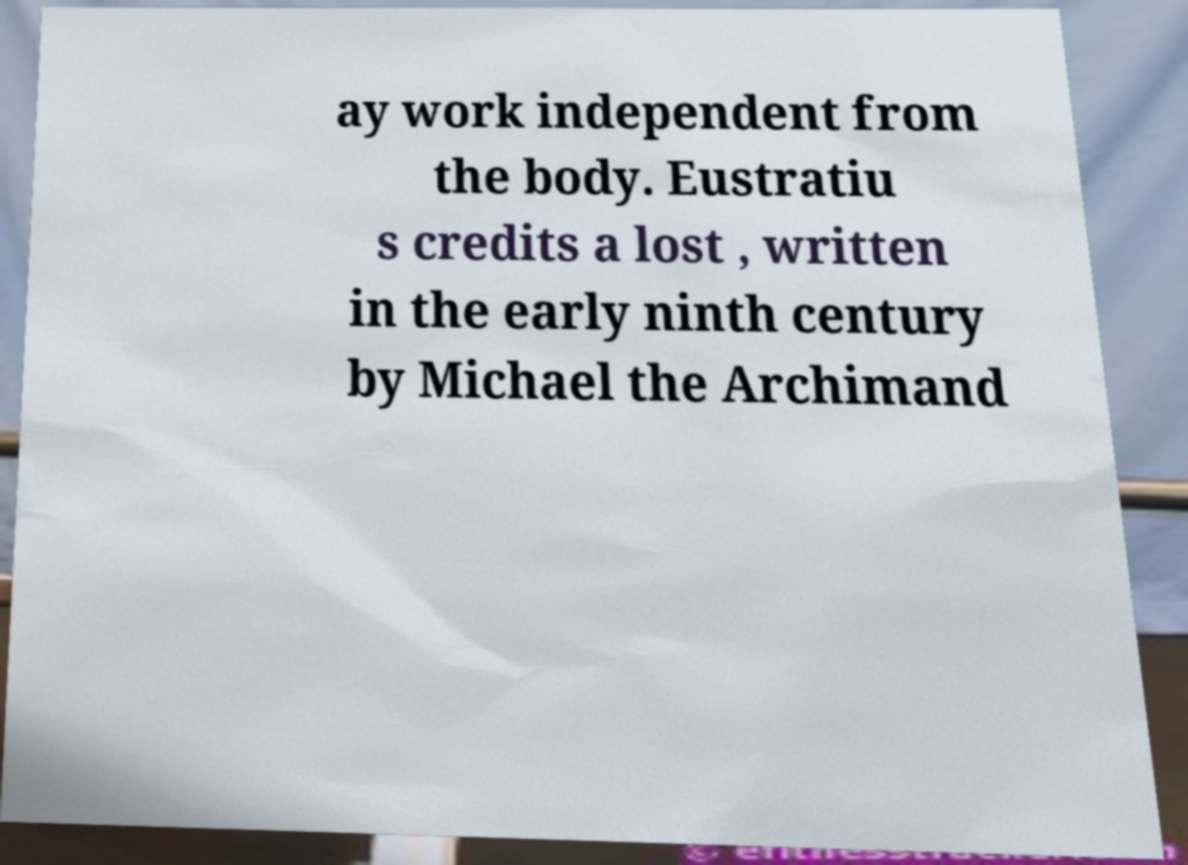Could you extract and type out the text from this image? ay work independent from the body. Eustratiu s credits a lost , written in the early ninth century by Michael the Archimand 